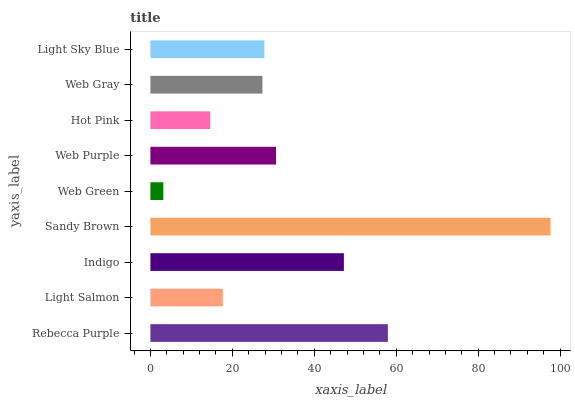Is Web Green the minimum?
Answer yes or no. Yes. Is Sandy Brown the maximum?
Answer yes or no. Yes. Is Light Salmon the minimum?
Answer yes or no. No. Is Light Salmon the maximum?
Answer yes or no. No. Is Rebecca Purple greater than Light Salmon?
Answer yes or no. Yes. Is Light Salmon less than Rebecca Purple?
Answer yes or no. Yes. Is Light Salmon greater than Rebecca Purple?
Answer yes or no. No. Is Rebecca Purple less than Light Salmon?
Answer yes or no. No. Is Light Sky Blue the high median?
Answer yes or no. Yes. Is Light Sky Blue the low median?
Answer yes or no. Yes. Is Web Purple the high median?
Answer yes or no. No. Is Hot Pink the low median?
Answer yes or no. No. 